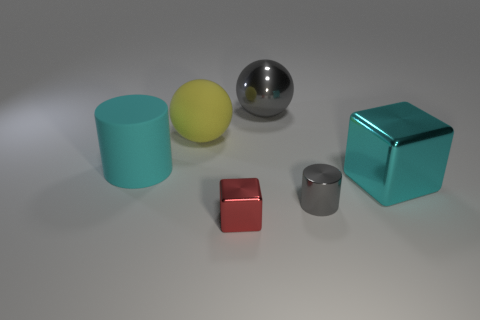Add 1 big gray metal objects. How many objects exist? 7 Subtract all balls. How many objects are left? 4 Subtract 0 green spheres. How many objects are left? 6 Subtract all red balls. Subtract all large yellow objects. How many objects are left? 5 Add 5 tiny cylinders. How many tiny cylinders are left? 6 Add 3 large matte spheres. How many large matte spheres exist? 4 